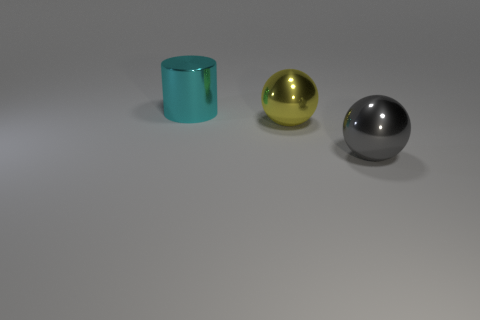How many gray objects are big shiny cylinders or large metallic spheres?
Your answer should be compact. 1. The cylinder that is made of the same material as the gray ball is what color?
Make the answer very short. Cyan. There is a sphere that is left of the big gray thing; what is its material?
Keep it short and to the point. Metal. Is the shape of the big metallic object that is behind the yellow shiny thing the same as the metallic object that is on the right side of the yellow metal object?
Provide a short and direct response. No. Are there any tiny red objects?
Your response must be concise. No. What material is the large gray thing that is the same shape as the yellow metal thing?
Your answer should be compact. Metal. There is a cyan cylinder; are there any large metal things to the right of it?
Keep it short and to the point. Yes. Are the thing that is in front of the yellow metallic sphere and the cylinder made of the same material?
Your answer should be very brief. Yes. What is the shape of the yellow metal thing?
Your response must be concise. Sphere. The big sphere that is behind the gray metallic ball in front of the yellow metal ball is what color?
Ensure brevity in your answer.  Yellow. 